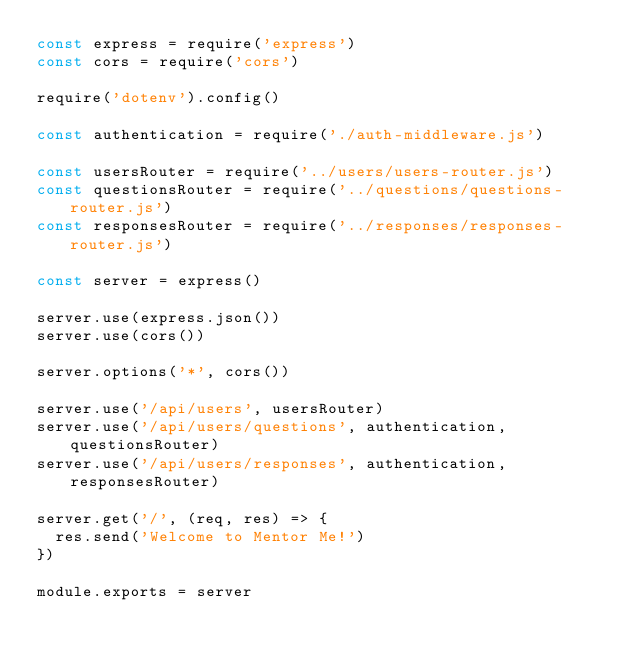Convert code to text. <code><loc_0><loc_0><loc_500><loc_500><_JavaScript_>const express = require('express')
const cors = require('cors')

require('dotenv').config()

const authentication = require('./auth-middleware.js')

const usersRouter = require('../users/users-router.js')
const questionsRouter = require('../questions/questions-router.js')
const responsesRouter = require('../responses/responses-router.js')

const server = express()

server.use(express.json())
server.use(cors())

server.options('*', cors())

server.use('/api/users', usersRouter)
server.use('/api/users/questions', authentication, questionsRouter)
server.use('/api/users/responses', authentication, responsesRouter)

server.get('/', (req, res) => {
  res.send('Welcome to Mentor Me!')
})

module.exports = server</code> 